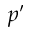<formula> <loc_0><loc_0><loc_500><loc_500>p ^ { \prime }</formula> 